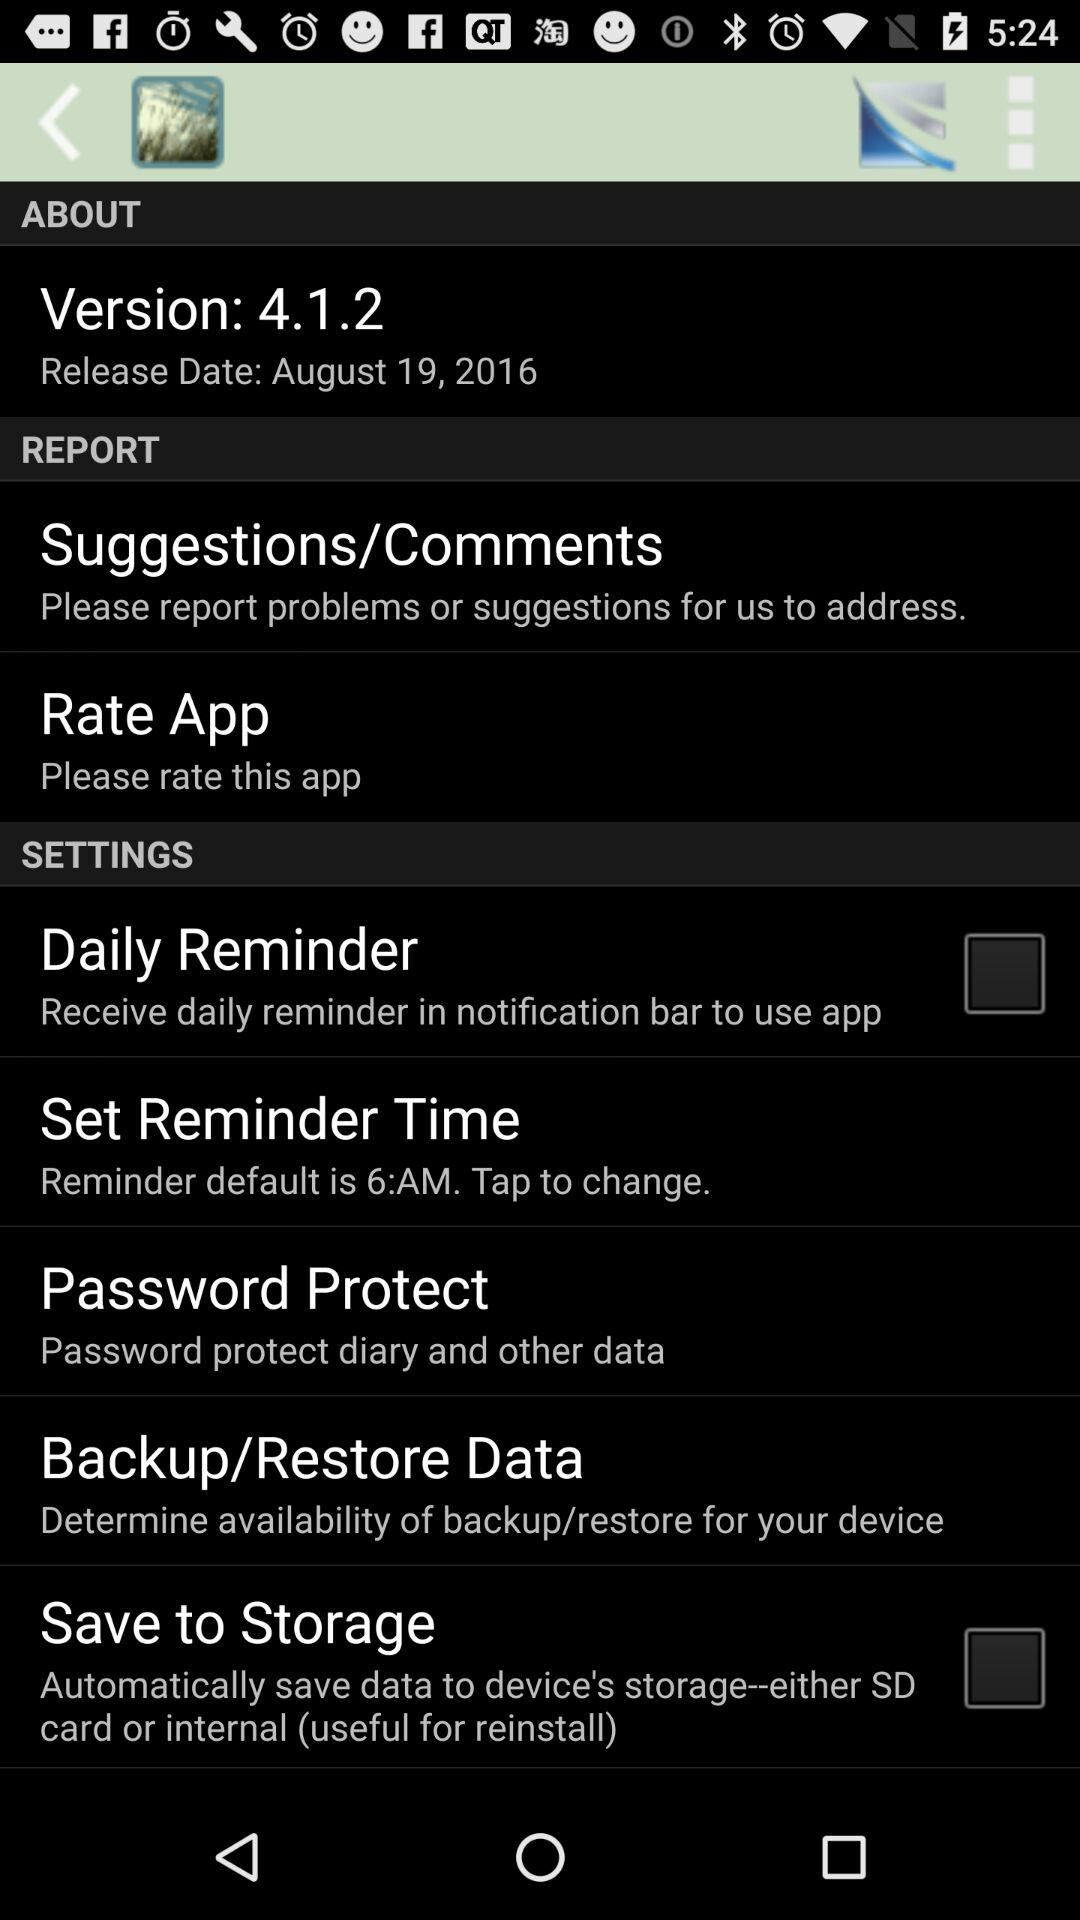What is the status of the "Daily Reminder"? The status is "off". 